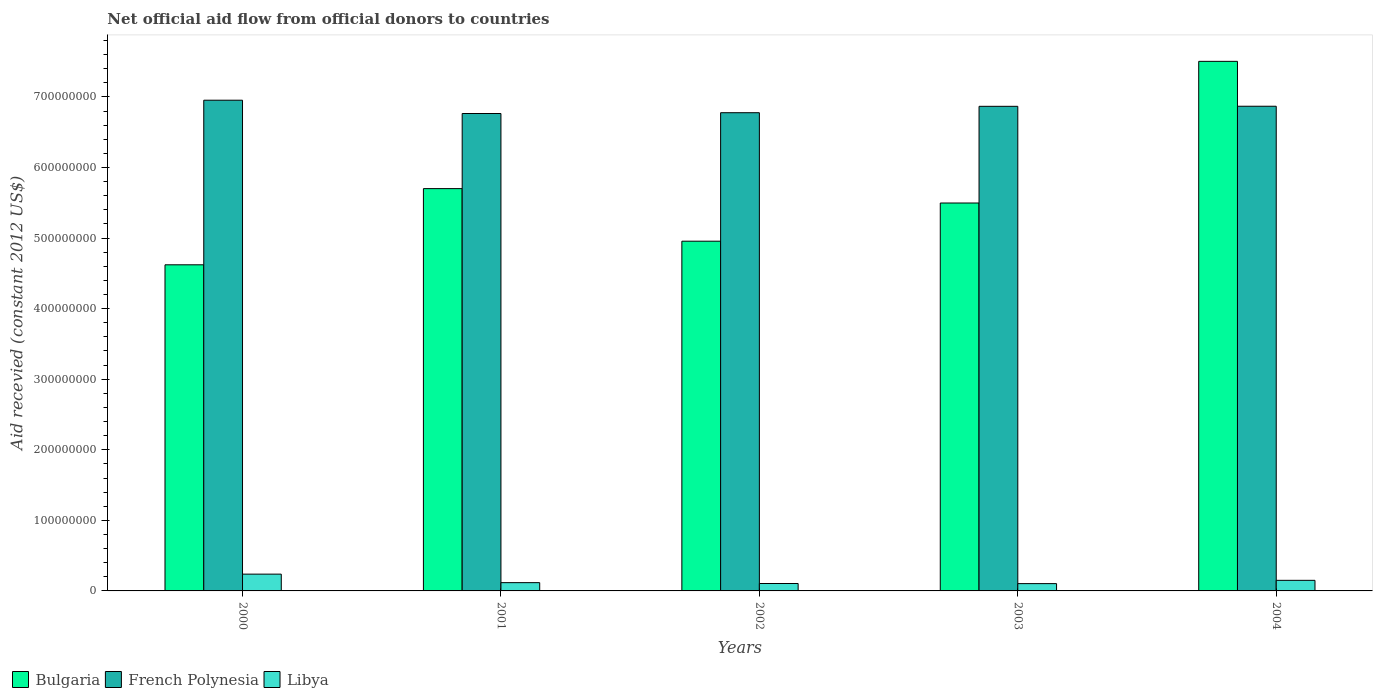How many different coloured bars are there?
Ensure brevity in your answer.  3. How many groups of bars are there?
Give a very brief answer. 5. Are the number of bars on each tick of the X-axis equal?
Make the answer very short. Yes. What is the total aid received in French Polynesia in 2000?
Give a very brief answer. 6.95e+08. Across all years, what is the maximum total aid received in Libya?
Ensure brevity in your answer.  2.38e+07. Across all years, what is the minimum total aid received in Libya?
Your response must be concise. 1.03e+07. In which year was the total aid received in Bulgaria maximum?
Offer a terse response. 2004. In which year was the total aid received in Bulgaria minimum?
Offer a very short reply. 2000. What is the total total aid received in French Polynesia in the graph?
Keep it short and to the point. 3.42e+09. What is the difference between the total aid received in Libya in 2002 and that in 2003?
Your response must be concise. 1.70e+05. What is the difference between the total aid received in French Polynesia in 2003 and the total aid received in Bulgaria in 2004?
Make the answer very short. -6.37e+07. What is the average total aid received in Bulgaria per year?
Your answer should be compact. 5.66e+08. In the year 2000, what is the difference between the total aid received in Bulgaria and total aid received in Libya?
Provide a succinct answer. 4.38e+08. What is the ratio of the total aid received in Libya in 2003 to that in 2004?
Ensure brevity in your answer.  0.69. Is the total aid received in French Polynesia in 2000 less than that in 2002?
Give a very brief answer. No. Is the difference between the total aid received in Bulgaria in 2000 and 2001 greater than the difference between the total aid received in Libya in 2000 and 2001?
Offer a terse response. No. What is the difference between the highest and the second highest total aid received in Libya?
Keep it short and to the point. 8.78e+06. What is the difference between the highest and the lowest total aid received in French Polynesia?
Make the answer very short. 1.88e+07. In how many years, is the total aid received in French Polynesia greater than the average total aid received in French Polynesia taken over all years?
Give a very brief answer. 3. Is the sum of the total aid received in French Polynesia in 2000 and 2001 greater than the maximum total aid received in Bulgaria across all years?
Your answer should be compact. Yes. What does the 3rd bar from the left in 2000 represents?
Keep it short and to the point. Libya. What does the 1st bar from the right in 2003 represents?
Your response must be concise. Libya. Are all the bars in the graph horizontal?
Your answer should be compact. No. What is the difference between two consecutive major ticks on the Y-axis?
Ensure brevity in your answer.  1.00e+08. Does the graph contain any zero values?
Keep it short and to the point. No. How are the legend labels stacked?
Keep it short and to the point. Horizontal. What is the title of the graph?
Your answer should be compact. Net official aid flow from official donors to countries. Does "Tuvalu" appear as one of the legend labels in the graph?
Offer a very short reply. No. What is the label or title of the Y-axis?
Offer a terse response. Aid recevied (constant 2012 US$). What is the Aid recevied (constant 2012 US$) of Bulgaria in 2000?
Your answer should be very brief. 4.62e+08. What is the Aid recevied (constant 2012 US$) of French Polynesia in 2000?
Offer a terse response. 6.95e+08. What is the Aid recevied (constant 2012 US$) of Libya in 2000?
Ensure brevity in your answer.  2.38e+07. What is the Aid recevied (constant 2012 US$) of Bulgaria in 2001?
Ensure brevity in your answer.  5.70e+08. What is the Aid recevied (constant 2012 US$) of French Polynesia in 2001?
Keep it short and to the point. 6.76e+08. What is the Aid recevied (constant 2012 US$) of Libya in 2001?
Give a very brief answer. 1.17e+07. What is the Aid recevied (constant 2012 US$) in Bulgaria in 2002?
Provide a short and direct response. 4.96e+08. What is the Aid recevied (constant 2012 US$) of French Polynesia in 2002?
Your response must be concise. 6.78e+08. What is the Aid recevied (constant 2012 US$) of Libya in 2002?
Keep it short and to the point. 1.05e+07. What is the Aid recevied (constant 2012 US$) of Bulgaria in 2003?
Ensure brevity in your answer.  5.50e+08. What is the Aid recevied (constant 2012 US$) in French Polynesia in 2003?
Make the answer very short. 6.87e+08. What is the Aid recevied (constant 2012 US$) of Libya in 2003?
Offer a terse response. 1.03e+07. What is the Aid recevied (constant 2012 US$) of Bulgaria in 2004?
Provide a succinct answer. 7.50e+08. What is the Aid recevied (constant 2012 US$) of French Polynesia in 2004?
Give a very brief answer. 6.87e+08. What is the Aid recevied (constant 2012 US$) in Libya in 2004?
Your answer should be compact. 1.50e+07. Across all years, what is the maximum Aid recevied (constant 2012 US$) in Bulgaria?
Keep it short and to the point. 7.50e+08. Across all years, what is the maximum Aid recevied (constant 2012 US$) in French Polynesia?
Keep it short and to the point. 6.95e+08. Across all years, what is the maximum Aid recevied (constant 2012 US$) in Libya?
Give a very brief answer. 2.38e+07. Across all years, what is the minimum Aid recevied (constant 2012 US$) in Bulgaria?
Make the answer very short. 4.62e+08. Across all years, what is the minimum Aid recevied (constant 2012 US$) of French Polynesia?
Your response must be concise. 6.76e+08. Across all years, what is the minimum Aid recevied (constant 2012 US$) in Libya?
Your answer should be very brief. 1.03e+07. What is the total Aid recevied (constant 2012 US$) in Bulgaria in the graph?
Make the answer very short. 2.83e+09. What is the total Aid recevied (constant 2012 US$) in French Polynesia in the graph?
Give a very brief answer. 3.42e+09. What is the total Aid recevied (constant 2012 US$) of Libya in the graph?
Provide a short and direct response. 7.14e+07. What is the difference between the Aid recevied (constant 2012 US$) in Bulgaria in 2000 and that in 2001?
Your answer should be very brief. -1.08e+08. What is the difference between the Aid recevied (constant 2012 US$) in French Polynesia in 2000 and that in 2001?
Your answer should be very brief. 1.88e+07. What is the difference between the Aid recevied (constant 2012 US$) of Libya in 2000 and that in 2001?
Ensure brevity in your answer.  1.21e+07. What is the difference between the Aid recevied (constant 2012 US$) of Bulgaria in 2000 and that in 2002?
Provide a succinct answer. -3.34e+07. What is the difference between the Aid recevied (constant 2012 US$) of French Polynesia in 2000 and that in 2002?
Your answer should be very brief. 1.77e+07. What is the difference between the Aid recevied (constant 2012 US$) in Libya in 2000 and that in 2002?
Your answer should be very brief. 1.33e+07. What is the difference between the Aid recevied (constant 2012 US$) in Bulgaria in 2000 and that in 2003?
Make the answer very short. -8.76e+07. What is the difference between the Aid recevied (constant 2012 US$) in French Polynesia in 2000 and that in 2003?
Offer a terse response. 8.64e+06. What is the difference between the Aid recevied (constant 2012 US$) in Libya in 2000 and that in 2003?
Your answer should be compact. 1.34e+07. What is the difference between the Aid recevied (constant 2012 US$) in Bulgaria in 2000 and that in 2004?
Offer a terse response. -2.88e+08. What is the difference between the Aid recevied (constant 2012 US$) of French Polynesia in 2000 and that in 2004?
Provide a succinct answer. 8.54e+06. What is the difference between the Aid recevied (constant 2012 US$) of Libya in 2000 and that in 2004?
Ensure brevity in your answer.  8.78e+06. What is the difference between the Aid recevied (constant 2012 US$) of Bulgaria in 2001 and that in 2002?
Your answer should be compact. 7.45e+07. What is the difference between the Aid recevied (constant 2012 US$) of French Polynesia in 2001 and that in 2002?
Your answer should be compact. -1.13e+06. What is the difference between the Aid recevied (constant 2012 US$) in Libya in 2001 and that in 2002?
Your answer should be compact. 1.22e+06. What is the difference between the Aid recevied (constant 2012 US$) in Bulgaria in 2001 and that in 2003?
Provide a succinct answer. 2.04e+07. What is the difference between the Aid recevied (constant 2012 US$) of French Polynesia in 2001 and that in 2003?
Offer a very short reply. -1.02e+07. What is the difference between the Aid recevied (constant 2012 US$) in Libya in 2001 and that in 2003?
Your answer should be very brief. 1.39e+06. What is the difference between the Aid recevied (constant 2012 US$) of Bulgaria in 2001 and that in 2004?
Keep it short and to the point. -1.80e+08. What is the difference between the Aid recevied (constant 2012 US$) of French Polynesia in 2001 and that in 2004?
Make the answer very short. -1.03e+07. What is the difference between the Aid recevied (constant 2012 US$) of Libya in 2001 and that in 2004?
Provide a short and direct response. -3.28e+06. What is the difference between the Aid recevied (constant 2012 US$) of Bulgaria in 2002 and that in 2003?
Provide a short and direct response. -5.41e+07. What is the difference between the Aid recevied (constant 2012 US$) in French Polynesia in 2002 and that in 2003?
Your response must be concise. -9.07e+06. What is the difference between the Aid recevied (constant 2012 US$) in Bulgaria in 2002 and that in 2004?
Offer a terse response. -2.55e+08. What is the difference between the Aid recevied (constant 2012 US$) in French Polynesia in 2002 and that in 2004?
Offer a terse response. -9.17e+06. What is the difference between the Aid recevied (constant 2012 US$) in Libya in 2002 and that in 2004?
Your answer should be very brief. -4.50e+06. What is the difference between the Aid recevied (constant 2012 US$) of Bulgaria in 2003 and that in 2004?
Offer a very short reply. -2.01e+08. What is the difference between the Aid recevied (constant 2012 US$) of Libya in 2003 and that in 2004?
Offer a very short reply. -4.67e+06. What is the difference between the Aid recevied (constant 2012 US$) in Bulgaria in 2000 and the Aid recevied (constant 2012 US$) in French Polynesia in 2001?
Offer a very short reply. -2.14e+08. What is the difference between the Aid recevied (constant 2012 US$) of Bulgaria in 2000 and the Aid recevied (constant 2012 US$) of Libya in 2001?
Provide a short and direct response. 4.50e+08. What is the difference between the Aid recevied (constant 2012 US$) of French Polynesia in 2000 and the Aid recevied (constant 2012 US$) of Libya in 2001?
Provide a short and direct response. 6.84e+08. What is the difference between the Aid recevied (constant 2012 US$) in Bulgaria in 2000 and the Aid recevied (constant 2012 US$) in French Polynesia in 2002?
Make the answer very short. -2.16e+08. What is the difference between the Aid recevied (constant 2012 US$) of Bulgaria in 2000 and the Aid recevied (constant 2012 US$) of Libya in 2002?
Offer a terse response. 4.52e+08. What is the difference between the Aid recevied (constant 2012 US$) of French Polynesia in 2000 and the Aid recevied (constant 2012 US$) of Libya in 2002?
Offer a very short reply. 6.85e+08. What is the difference between the Aid recevied (constant 2012 US$) of Bulgaria in 2000 and the Aid recevied (constant 2012 US$) of French Polynesia in 2003?
Give a very brief answer. -2.25e+08. What is the difference between the Aid recevied (constant 2012 US$) in Bulgaria in 2000 and the Aid recevied (constant 2012 US$) in Libya in 2003?
Provide a succinct answer. 4.52e+08. What is the difference between the Aid recevied (constant 2012 US$) in French Polynesia in 2000 and the Aid recevied (constant 2012 US$) in Libya in 2003?
Provide a short and direct response. 6.85e+08. What is the difference between the Aid recevied (constant 2012 US$) in Bulgaria in 2000 and the Aid recevied (constant 2012 US$) in French Polynesia in 2004?
Offer a terse response. -2.25e+08. What is the difference between the Aid recevied (constant 2012 US$) of Bulgaria in 2000 and the Aid recevied (constant 2012 US$) of Libya in 2004?
Your answer should be compact. 4.47e+08. What is the difference between the Aid recevied (constant 2012 US$) in French Polynesia in 2000 and the Aid recevied (constant 2012 US$) in Libya in 2004?
Make the answer very short. 6.80e+08. What is the difference between the Aid recevied (constant 2012 US$) of Bulgaria in 2001 and the Aid recevied (constant 2012 US$) of French Polynesia in 2002?
Provide a short and direct response. -1.08e+08. What is the difference between the Aid recevied (constant 2012 US$) of Bulgaria in 2001 and the Aid recevied (constant 2012 US$) of Libya in 2002?
Your response must be concise. 5.60e+08. What is the difference between the Aid recevied (constant 2012 US$) in French Polynesia in 2001 and the Aid recevied (constant 2012 US$) in Libya in 2002?
Keep it short and to the point. 6.66e+08. What is the difference between the Aid recevied (constant 2012 US$) of Bulgaria in 2001 and the Aid recevied (constant 2012 US$) of French Polynesia in 2003?
Offer a very short reply. -1.17e+08. What is the difference between the Aid recevied (constant 2012 US$) of Bulgaria in 2001 and the Aid recevied (constant 2012 US$) of Libya in 2003?
Provide a succinct answer. 5.60e+08. What is the difference between the Aid recevied (constant 2012 US$) in French Polynesia in 2001 and the Aid recevied (constant 2012 US$) in Libya in 2003?
Your answer should be very brief. 6.66e+08. What is the difference between the Aid recevied (constant 2012 US$) of Bulgaria in 2001 and the Aid recevied (constant 2012 US$) of French Polynesia in 2004?
Your response must be concise. -1.17e+08. What is the difference between the Aid recevied (constant 2012 US$) in Bulgaria in 2001 and the Aid recevied (constant 2012 US$) in Libya in 2004?
Make the answer very short. 5.55e+08. What is the difference between the Aid recevied (constant 2012 US$) in French Polynesia in 2001 and the Aid recevied (constant 2012 US$) in Libya in 2004?
Give a very brief answer. 6.61e+08. What is the difference between the Aid recevied (constant 2012 US$) in Bulgaria in 2002 and the Aid recevied (constant 2012 US$) in French Polynesia in 2003?
Make the answer very short. -1.91e+08. What is the difference between the Aid recevied (constant 2012 US$) of Bulgaria in 2002 and the Aid recevied (constant 2012 US$) of Libya in 2003?
Provide a succinct answer. 4.85e+08. What is the difference between the Aid recevied (constant 2012 US$) in French Polynesia in 2002 and the Aid recevied (constant 2012 US$) in Libya in 2003?
Your response must be concise. 6.67e+08. What is the difference between the Aid recevied (constant 2012 US$) in Bulgaria in 2002 and the Aid recevied (constant 2012 US$) in French Polynesia in 2004?
Offer a very short reply. -1.91e+08. What is the difference between the Aid recevied (constant 2012 US$) of Bulgaria in 2002 and the Aid recevied (constant 2012 US$) of Libya in 2004?
Provide a short and direct response. 4.81e+08. What is the difference between the Aid recevied (constant 2012 US$) in French Polynesia in 2002 and the Aid recevied (constant 2012 US$) in Libya in 2004?
Your answer should be very brief. 6.63e+08. What is the difference between the Aid recevied (constant 2012 US$) in Bulgaria in 2003 and the Aid recevied (constant 2012 US$) in French Polynesia in 2004?
Your answer should be very brief. -1.37e+08. What is the difference between the Aid recevied (constant 2012 US$) of Bulgaria in 2003 and the Aid recevied (constant 2012 US$) of Libya in 2004?
Offer a terse response. 5.35e+08. What is the difference between the Aid recevied (constant 2012 US$) of French Polynesia in 2003 and the Aid recevied (constant 2012 US$) of Libya in 2004?
Offer a terse response. 6.72e+08. What is the average Aid recevied (constant 2012 US$) in Bulgaria per year?
Your answer should be compact. 5.66e+08. What is the average Aid recevied (constant 2012 US$) in French Polynesia per year?
Keep it short and to the point. 6.85e+08. What is the average Aid recevied (constant 2012 US$) in Libya per year?
Keep it short and to the point. 1.43e+07. In the year 2000, what is the difference between the Aid recevied (constant 2012 US$) in Bulgaria and Aid recevied (constant 2012 US$) in French Polynesia?
Your answer should be compact. -2.33e+08. In the year 2000, what is the difference between the Aid recevied (constant 2012 US$) of Bulgaria and Aid recevied (constant 2012 US$) of Libya?
Offer a very short reply. 4.38e+08. In the year 2000, what is the difference between the Aid recevied (constant 2012 US$) of French Polynesia and Aid recevied (constant 2012 US$) of Libya?
Offer a terse response. 6.72e+08. In the year 2001, what is the difference between the Aid recevied (constant 2012 US$) in Bulgaria and Aid recevied (constant 2012 US$) in French Polynesia?
Give a very brief answer. -1.06e+08. In the year 2001, what is the difference between the Aid recevied (constant 2012 US$) in Bulgaria and Aid recevied (constant 2012 US$) in Libya?
Make the answer very short. 5.58e+08. In the year 2001, what is the difference between the Aid recevied (constant 2012 US$) in French Polynesia and Aid recevied (constant 2012 US$) in Libya?
Make the answer very short. 6.65e+08. In the year 2002, what is the difference between the Aid recevied (constant 2012 US$) of Bulgaria and Aid recevied (constant 2012 US$) of French Polynesia?
Provide a succinct answer. -1.82e+08. In the year 2002, what is the difference between the Aid recevied (constant 2012 US$) in Bulgaria and Aid recevied (constant 2012 US$) in Libya?
Provide a succinct answer. 4.85e+08. In the year 2002, what is the difference between the Aid recevied (constant 2012 US$) of French Polynesia and Aid recevied (constant 2012 US$) of Libya?
Ensure brevity in your answer.  6.67e+08. In the year 2003, what is the difference between the Aid recevied (constant 2012 US$) in Bulgaria and Aid recevied (constant 2012 US$) in French Polynesia?
Provide a succinct answer. -1.37e+08. In the year 2003, what is the difference between the Aid recevied (constant 2012 US$) in Bulgaria and Aid recevied (constant 2012 US$) in Libya?
Your answer should be very brief. 5.39e+08. In the year 2003, what is the difference between the Aid recevied (constant 2012 US$) in French Polynesia and Aid recevied (constant 2012 US$) in Libya?
Provide a short and direct response. 6.76e+08. In the year 2004, what is the difference between the Aid recevied (constant 2012 US$) of Bulgaria and Aid recevied (constant 2012 US$) of French Polynesia?
Provide a succinct answer. 6.36e+07. In the year 2004, what is the difference between the Aid recevied (constant 2012 US$) in Bulgaria and Aid recevied (constant 2012 US$) in Libya?
Offer a terse response. 7.35e+08. In the year 2004, what is the difference between the Aid recevied (constant 2012 US$) of French Polynesia and Aid recevied (constant 2012 US$) of Libya?
Provide a succinct answer. 6.72e+08. What is the ratio of the Aid recevied (constant 2012 US$) in Bulgaria in 2000 to that in 2001?
Keep it short and to the point. 0.81. What is the ratio of the Aid recevied (constant 2012 US$) in French Polynesia in 2000 to that in 2001?
Make the answer very short. 1.03. What is the ratio of the Aid recevied (constant 2012 US$) in Libya in 2000 to that in 2001?
Your answer should be compact. 2.03. What is the ratio of the Aid recevied (constant 2012 US$) in Bulgaria in 2000 to that in 2002?
Provide a succinct answer. 0.93. What is the ratio of the Aid recevied (constant 2012 US$) in French Polynesia in 2000 to that in 2002?
Your answer should be compact. 1.03. What is the ratio of the Aid recevied (constant 2012 US$) in Libya in 2000 to that in 2002?
Offer a very short reply. 2.26. What is the ratio of the Aid recevied (constant 2012 US$) of Bulgaria in 2000 to that in 2003?
Your response must be concise. 0.84. What is the ratio of the Aid recevied (constant 2012 US$) of French Polynesia in 2000 to that in 2003?
Your response must be concise. 1.01. What is the ratio of the Aid recevied (constant 2012 US$) of Libya in 2000 to that in 2003?
Keep it short and to the point. 2.3. What is the ratio of the Aid recevied (constant 2012 US$) in Bulgaria in 2000 to that in 2004?
Provide a short and direct response. 0.62. What is the ratio of the Aid recevied (constant 2012 US$) of French Polynesia in 2000 to that in 2004?
Keep it short and to the point. 1.01. What is the ratio of the Aid recevied (constant 2012 US$) in Libya in 2000 to that in 2004?
Your response must be concise. 1.58. What is the ratio of the Aid recevied (constant 2012 US$) in Bulgaria in 2001 to that in 2002?
Ensure brevity in your answer.  1.15. What is the ratio of the Aid recevied (constant 2012 US$) of Libya in 2001 to that in 2002?
Keep it short and to the point. 1.12. What is the ratio of the Aid recevied (constant 2012 US$) in Bulgaria in 2001 to that in 2003?
Your answer should be very brief. 1.04. What is the ratio of the Aid recevied (constant 2012 US$) in French Polynesia in 2001 to that in 2003?
Keep it short and to the point. 0.99. What is the ratio of the Aid recevied (constant 2012 US$) of Libya in 2001 to that in 2003?
Make the answer very short. 1.13. What is the ratio of the Aid recevied (constant 2012 US$) in Bulgaria in 2001 to that in 2004?
Your response must be concise. 0.76. What is the ratio of the Aid recevied (constant 2012 US$) of French Polynesia in 2001 to that in 2004?
Provide a succinct answer. 0.98. What is the ratio of the Aid recevied (constant 2012 US$) in Libya in 2001 to that in 2004?
Your response must be concise. 0.78. What is the ratio of the Aid recevied (constant 2012 US$) of Bulgaria in 2002 to that in 2003?
Provide a short and direct response. 0.9. What is the ratio of the Aid recevied (constant 2012 US$) in Libya in 2002 to that in 2003?
Keep it short and to the point. 1.02. What is the ratio of the Aid recevied (constant 2012 US$) of Bulgaria in 2002 to that in 2004?
Your response must be concise. 0.66. What is the ratio of the Aid recevied (constant 2012 US$) in French Polynesia in 2002 to that in 2004?
Give a very brief answer. 0.99. What is the ratio of the Aid recevied (constant 2012 US$) in Libya in 2002 to that in 2004?
Provide a succinct answer. 0.7. What is the ratio of the Aid recevied (constant 2012 US$) of Bulgaria in 2003 to that in 2004?
Offer a terse response. 0.73. What is the ratio of the Aid recevied (constant 2012 US$) in French Polynesia in 2003 to that in 2004?
Your answer should be compact. 1. What is the ratio of the Aid recevied (constant 2012 US$) of Libya in 2003 to that in 2004?
Make the answer very short. 0.69. What is the difference between the highest and the second highest Aid recevied (constant 2012 US$) of Bulgaria?
Offer a very short reply. 1.80e+08. What is the difference between the highest and the second highest Aid recevied (constant 2012 US$) of French Polynesia?
Provide a short and direct response. 8.54e+06. What is the difference between the highest and the second highest Aid recevied (constant 2012 US$) of Libya?
Give a very brief answer. 8.78e+06. What is the difference between the highest and the lowest Aid recevied (constant 2012 US$) of Bulgaria?
Offer a terse response. 2.88e+08. What is the difference between the highest and the lowest Aid recevied (constant 2012 US$) of French Polynesia?
Offer a very short reply. 1.88e+07. What is the difference between the highest and the lowest Aid recevied (constant 2012 US$) of Libya?
Offer a terse response. 1.34e+07. 